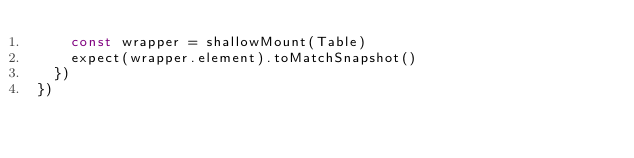<code> <loc_0><loc_0><loc_500><loc_500><_JavaScript_>    const wrapper = shallowMount(Table)
    expect(wrapper.element).toMatchSnapshot()
  })
})
</code> 